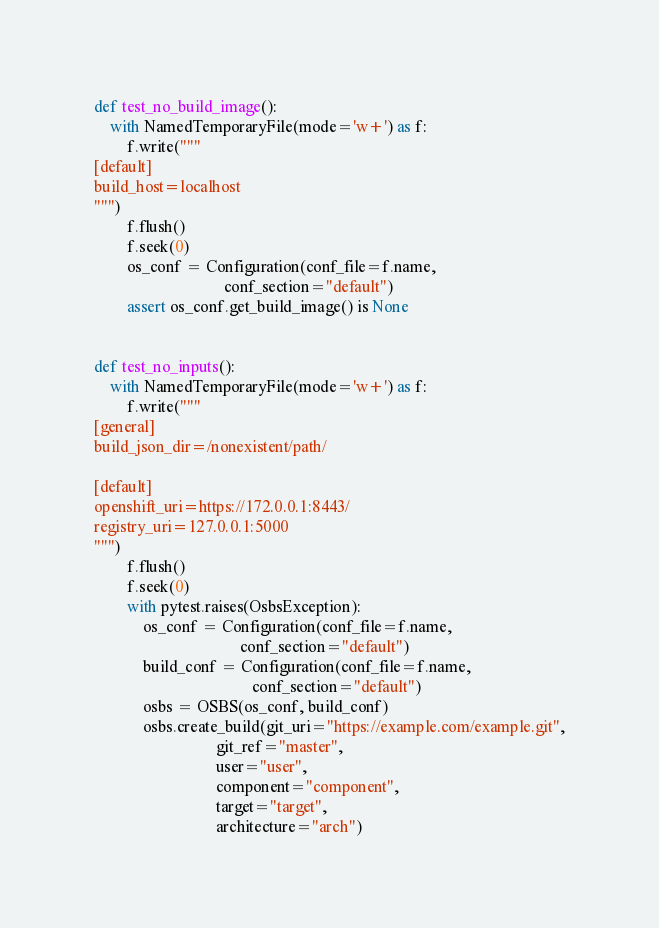<code> <loc_0><loc_0><loc_500><loc_500><_Python_>def test_no_build_image():
    with NamedTemporaryFile(mode='w+') as f:
        f.write("""
[default]
build_host=localhost
""")
        f.flush()
        f.seek(0)
        os_conf = Configuration(conf_file=f.name,
                                conf_section="default")
        assert os_conf.get_build_image() is None


def test_no_inputs():
    with NamedTemporaryFile(mode='w+') as f:
        f.write("""
[general]
build_json_dir=/nonexistent/path/

[default]
openshift_uri=https://172.0.0.1:8443/
registry_uri=127.0.0.1:5000
""")
        f.flush()
        f.seek(0)
        with pytest.raises(OsbsException):
            os_conf = Configuration(conf_file=f.name,
                                    conf_section="default")
            build_conf = Configuration(conf_file=f.name,
                                       conf_section="default")
            osbs = OSBS(os_conf, build_conf)
            osbs.create_build(git_uri="https://example.com/example.git",
                              git_ref="master",
                              user="user",
                              component="component",
                              target="target",
                              architecture="arch")
</code> 